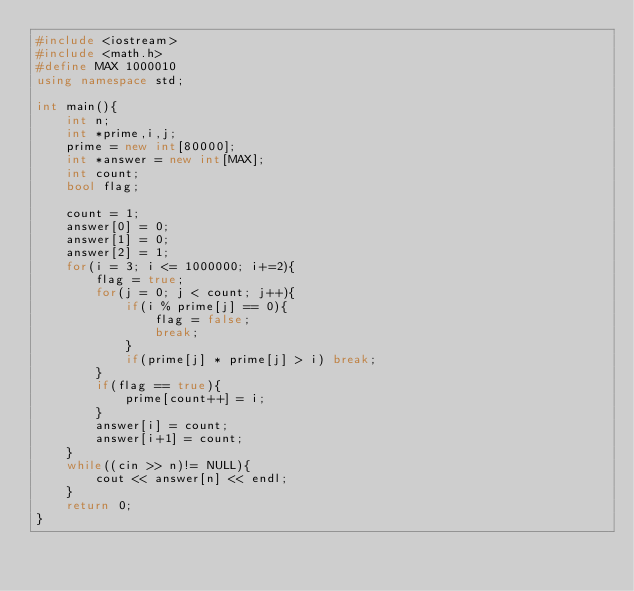Convert code to text. <code><loc_0><loc_0><loc_500><loc_500><_C++_>#include <iostream>
#include <math.h>
#define MAX 1000010
using namespace std;

int main(){
	int n;
	int *prime,i,j;
	prime = new int[80000];
	int *answer = new int[MAX];
	int count;
	bool flag;

	count = 1;
	answer[0] = 0;
	answer[1] = 0;
	answer[2] = 1;
	for(i = 3; i <= 1000000; i+=2){
		flag = true;
		for(j = 0; j < count; j++){
			if(i % prime[j] == 0){
				flag = false;
				break;
			}
			if(prime[j] * prime[j] > i) break;
		}
		if(flag == true){
			prime[count++] = i;
		}
		answer[i] = count;
		answer[i+1] = count;
	}
	while((cin >> n)!= NULL){
		cout << answer[n] << endl;
	}
	return 0;
}</code> 